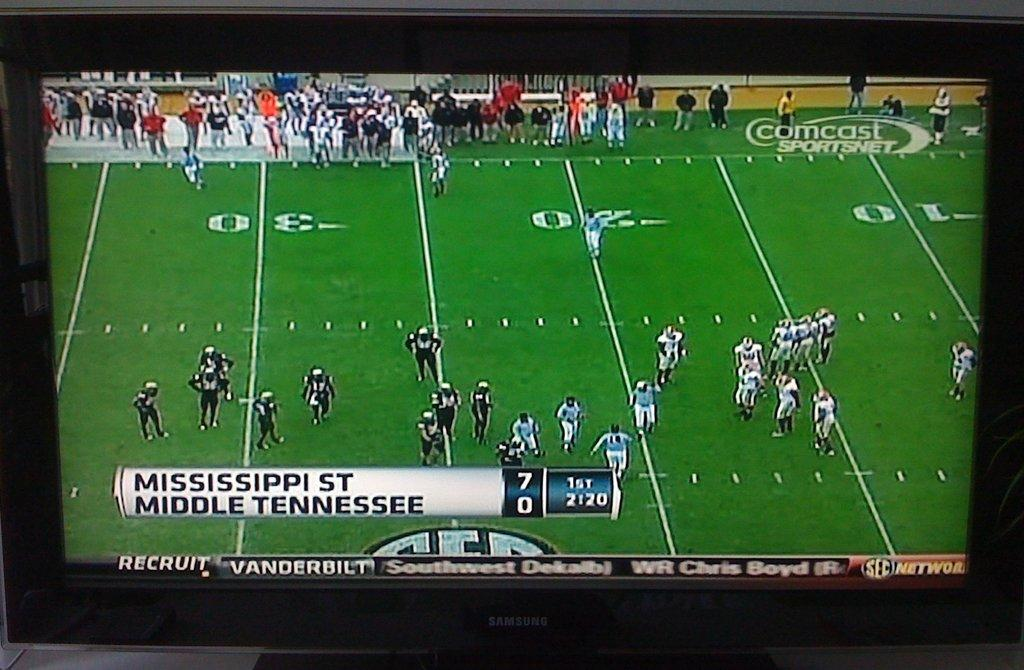Provide a one-sentence caption for the provided image. a Mississippi St team winning by 7 against another team. 